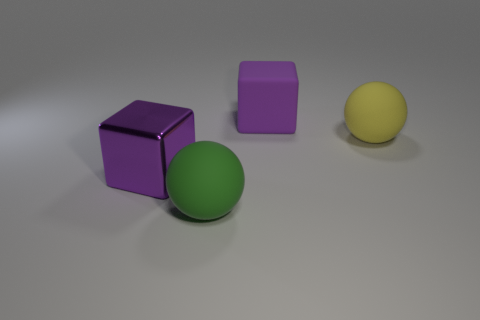Add 1 big yellow rubber things. How many objects exist? 5 Add 4 rubber things. How many rubber things are left? 7 Add 1 cyan metallic things. How many cyan metallic things exist? 1 Subtract 0 red blocks. How many objects are left? 4 Subtract all large cyan metal cylinders. Subtract all purple metal blocks. How many objects are left? 3 